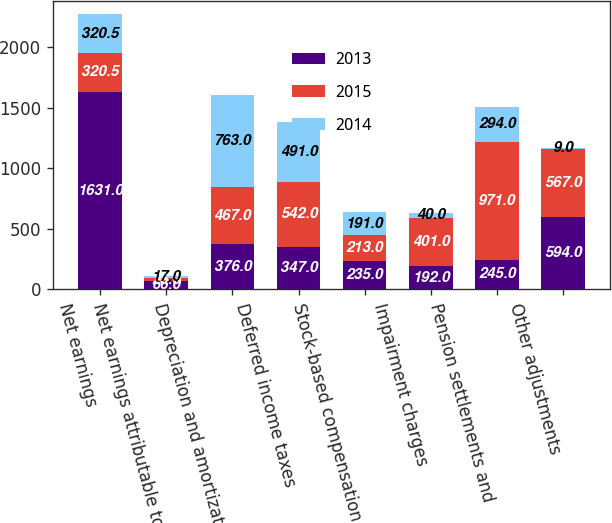Convert chart to OTSL. <chart><loc_0><loc_0><loc_500><loc_500><stacked_bar_chart><ecel><fcel>Net earnings<fcel>Net earnings attributable to<fcel>Depreciation and amortization<fcel>Deferred income taxes<fcel>Stock-based compensation<fcel>Impairment charges<fcel>Pension settlements and<fcel>Other adjustments<nl><fcel>2013<fcel>1631<fcel>66<fcel>376<fcel>347<fcel>235<fcel>192<fcel>245<fcel>594<nl><fcel>2015<fcel>320.5<fcel>25<fcel>467<fcel>542<fcel>213<fcel>401<fcel>971<fcel>567<nl><fcel>2014<fcel>320.5<fcel>17<fcel>763<fcel>491<fcel>191<fcel>40<fcel>294<fcel>9<nl></chart> 